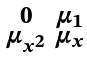Convert formula to latex. <formula><loc_0><loc_0><loc_500><loc_500>\begin{smallmatrix} 0 & \mu _ { 1 } \\ \mu _ { x ^ { 2 } } & \mu _ { x } \end{smallmatrix}</formula> 